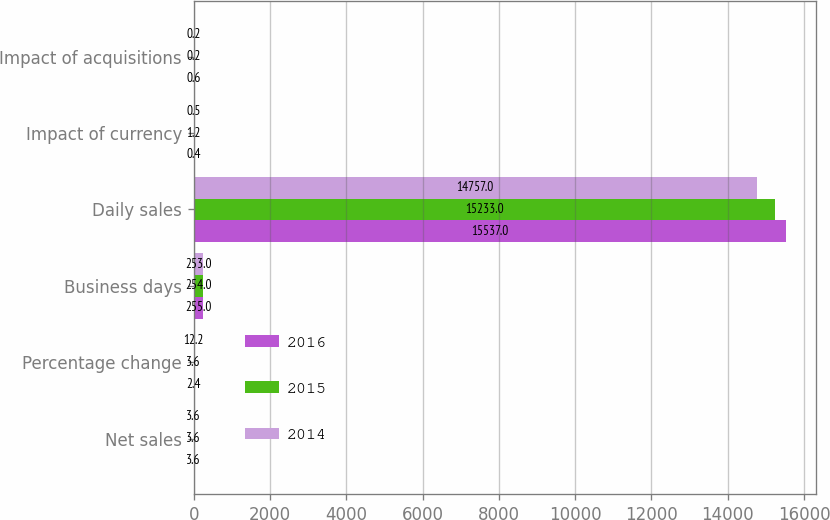Convert chart to OTSL. <chart><loc_0><loc_0><loc_500><loc_500><stacked_bar_chart><ecel><fcel>Net sales<fcel>Percentage change<fcel>Business days<fcel>Daily sales<fcel>Impact of currency<fcel>Impact of acquisitions<nl><fcel>2016<fcel>3.6<fcel>2.4<fcel>255<fcel>15537<fcel>0.4<fcel>0.6<nl><fcel>2015<fcel>3.6<fcel>3.6<fcel>254<fcel>15233<fcel>1.2<fcel>0.2<nl><fcel>2014<fcel>3.6<fcel>12.2<fcel>253<fcel>14757<fcel>0.5<fcel>0.2<nl></chart> 